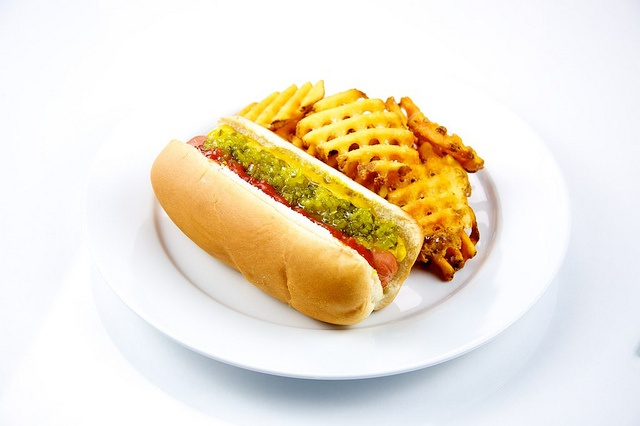Describe the objects in this image and their specific colors. I can see a hot dog in white, orange, khaki, and beige tones in this image. 